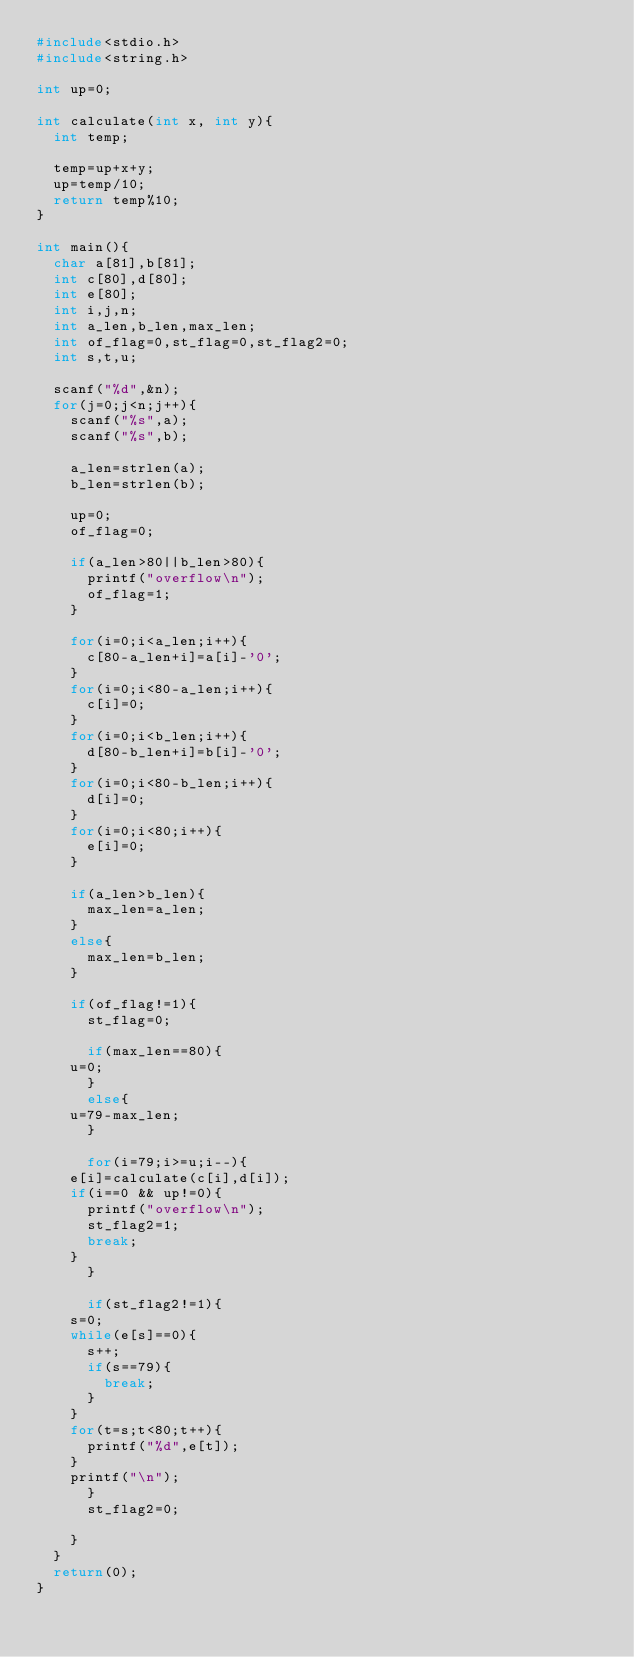<code> <loc_0><loc_0><loc_500><loc_500><_C_>#include<stdio.h>
#include<string.h>

int up=0;

int calculate(int x, int y){
  int temp;

  temp=up+x+y;
  up=temp/10;
  return temp%10;
}

int main(){
  char a[81],b[81];
  int c[80],d[80];
  int e[80];
  int i,j,n;
  int a_len,b_len,max_len;
  int of_flag=0,st_flag=0,st_flag2=0;
  int s,t,u;
  
  scanf("%d",&n);
  for(j=0;j<n;j++){
    scanf("%s",a);
    scanf("%s",b);
    
    a_len=strlen(a);
    b_len=strlen(b);

    up=0;
    of_flag=0;

    if(a_len>80||b_len>80){
      printf("overflow\n");
      of_flag=1;
    }
    
    for(i=0;i<a_len;i++){
      c[80-a_len+i]=a[i]-'0';
    }
    for(i=0;i<80-a_len;i++){
      c[i]=0;
    }
    for(i=0;i<b_len;i++){
      d[80-b_len+i]=b[i]-'0';
    }
    for(i=0;i<80-b_len;i++){
      d[i]=0;
    }
    for(i=0;i<80;i++){
      e[i]=0;
    }

    if(a_len>b_len){
      max_len=a_len;
    }
    else{
      max_len=b_len;
    }

    if(of_flag!=1){
      st_flag=0;

      if(max_len==80){
	u=0;
      }
      else{
	u=79-max_len;
      }

      for(i=79;i>=u;i--){
	e[i]=calculate(c[i],d[i]);
	if(i==0 && up!=0){
	  printf("overflow\n");
	  st_flag2=1;
	  break;
	}
      }

      if(st_flag2!=1){
	s=0;
	while(e[s]==0){
	  s++;
	  if(s==79){
	    break;
	  }
	}
	for(t=s;t<80;t++){
	  printf("%d",e[t]);
	}
	printf("\n");
      }
      st_flag2=0;

    }
  }
  return(0);
}</code> 